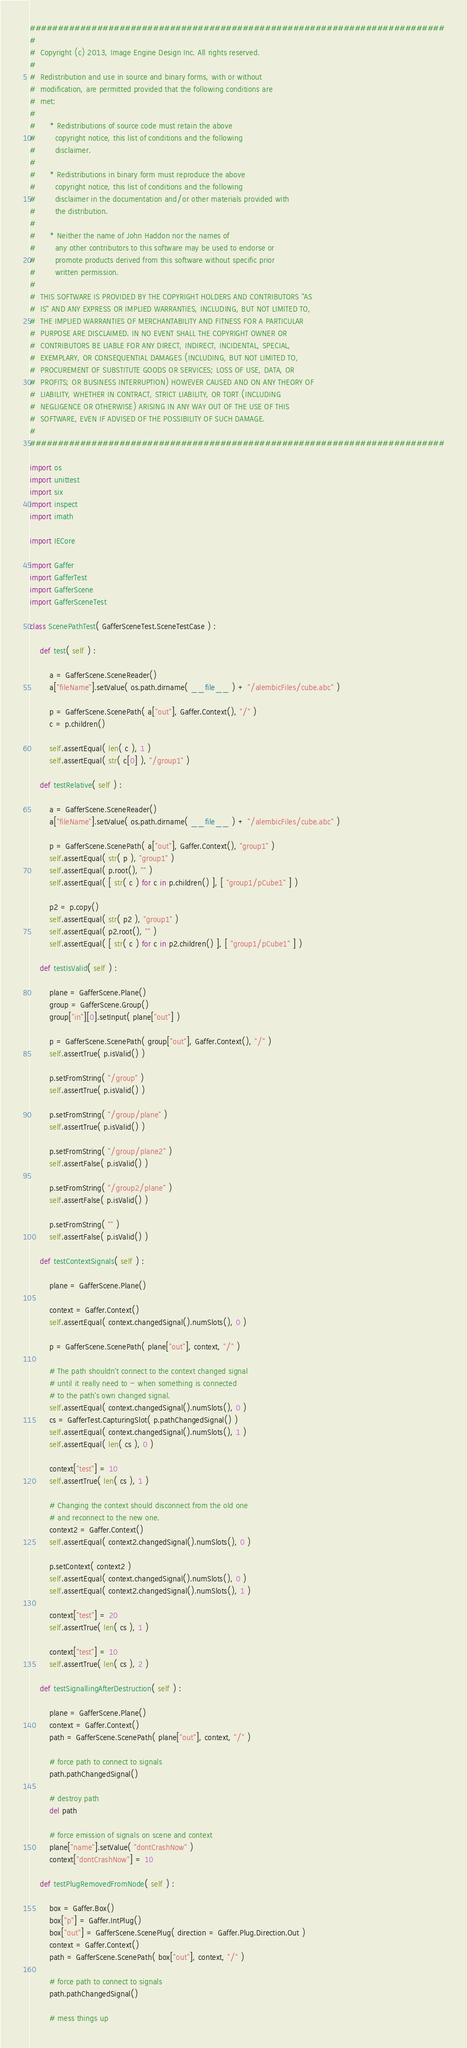Convert code to text. <code><loc_0><loc_0><loc_500><loc_500><_Python_>##########################################################################
#
#  Copyright (c) 2013, Image Engine Design Inc. All rights reserved.
#
#  Redistribution and use in source and binary forms, with or without
#  modification, are permitted provided that the following conditions are
#  met:
#
#      * Redistributions of source code must retain the above
#        copyright notice, this list of conditions and the following
#        disclaimer.
#
#      * Redistributions in binary form must reproduce the above
#        copyright notice, this list of conditions and the following
#        disclaimer in the documentation and/or other materials provided with
#        the distribution.
#
#      * Neither the name of John Haddon nor the names of
#        any other contributors to this software may be used to endorse or
#        promote products derived from this software without specific prior
#        written permission.
#
#  THIS SOFTWARE IS PROVIDED BY THE COPYRIGHT HOLDERS AND CONTRIBUTORS "AS
#  IS" AND ANY EXPRESS OR IMPLIED WARRANTIES, INCLUDING, BUT NOT LIMITED TO,
#  THE IMPLIED WARRANTIES OF MERCHANTABILITY AND FITNESS FOR A PARTICULAR
#  PURPOSE ARE DISCLAIMED. IN NO EVENT SHALL THE COPYRIGHT OWNER OR
#  CONTRIBUTORS BE LIABLE FOR ANY DIRECT, INDIRECT, INCIDENTAL, SPECIAL,
#  EXEMPLARY, OR CONSEQUENTIAL DAMAGES (INCLUDING, BUT NOT LIMITED TO,
#  PROCUREMENT OF SUBSTITUTE GOODS OR SERVICES; LOSS OF USE, DATA, OR
#  PROFITS; OR BUSINESS INTERRUPTION) HOWEVER CAUSED AND ON ANY THEORY OF
#  LIABILITY, WHETHER IN CONTRACT, STRICT LIABILITY, OR TORT (INCLUDING
#  NEGLIGENCE OR OTHERWISE) ARISING IN ANY WAY OUT OF THE USE OF THIS
#  SOFTWARE, EVEN IF ADVISED OF THE POSSIBILITY OF SUCH DAMAGE.
#
##########################################################################

import os
import unittest
import six
import inspect
import imath

import IECore

import Gaffer
import GafferTest
import GafferScene
import GafferSceneTest

class ScenePathTest( GafferSceneTest.SceneTestCase ) :

	def test( self ) :

		a = GafferScene.SceneReader()
		a["fileName"].setValue( os.path.dirname( __file__ ) + "/alembicFiles/cube.abc" )

		p = GafferScene.ScenePath( a["out"], Gaffer.Context(), "/" )
		c = p.children()

		self.assertEqual( len( c ), 1 )
		self.assertEqual( str( c[0] ), "/group1" )

	def testRelative( self ) :

		a = GafferScene.SceneReader()
		a["fileName"].setValue( os.path.dirname( __file__ ) + "/alembicFiles/cube.abc" )

		p = GafferScene.ScenePath( a["out"], Gaffer.Context(), "group1" )
		self.assertEqual( str( p ), "group1" )
		self.assertEqual( p.root(), "" )
		self.assertEqual( [ str( c ) for c in p.children() ], [ "group1/pCube1" ] )

		p2 = p.copy()
		self.assertEqual( str( p2 ), "group1" )
		self.assertEqual( p2.root(), "" )
		self.assertEqual( [ str( c ) for c in p2.children() ], [ "group1/pCube1" ] )

	def testIsValid( self ) :

		plane = GafferScene.Plane()
		group = GafferScene.Group()
		group["in"][0].setInput( plane["out"] )

		p = GafferScene.ScenePath( group["out"], Gaffer.Context(), "/" )
		self.assertTrue( p.isValid() )

		p.setFromString( "/group" )
		self.assertTrue( p.isValid() )

		p.setFromString( "/group/plane" )
		self.assertTrue( p.isValid() )

		p.setFromString( "/group/plane2" )
		self.assertFalse( p.isValid() )

		p.setFromString( "/group2/plane" )
		self.assertFalse( p.isValid() )

		p.setFromString( "" )
		self.assertFalse( p.isValid() )

	def testContextSignals( self ) :

		plane = GafferScene.Plane()

		context = Gaffer.Context()
		self.assertEqual( context.changedSignal().numSlots(), 0 )

		p = GafferScene.ScenePath( plane["out"], context, "/" )

		# The path shouldn't connect to the context changed signal
		# until it really need to - when something is connected
		# to the path's own changed signal.
		self.assertEqual( context.changedSignal().numSlots(), 0 )
		cs = GafferTest.CapturingSlot( p.pathChangedSignal() )
		self.assertEqual( context.changedSignal().numSlots(), 1 )
		self.assertEqual( len( cs ), 0 )

		context["test"] = 10
		self.assertTrue( len( cs ), 1 )

		# Changing the context should disconnect from the old one
		# and reconnect to the new one.
		context2 = Gaffer.Context()
		self.assertEqual( context2.changedSignal().numSlots(), 0 )

		p.setContext( context2 )
		self.assertEqual( context.changedSignal().numSlots(), 0 )
		self.assertEqual( context2.changedSignal().numSlots(), 1 )

		context["test"] = 20
		self.assertTrue( len( cs ), 1 )

		context["test"] = 10
		self.assertTrue( len( cs ), 2 )

	def testSignallingAfterDestruction( self ) :

		plane = GafferScene.Plane()
		context = Gaffer.Context()
		path = GafferScene.ScenePath( plane["out"], context, "/" )

		# force path to connect to signals
		path.pathChangedSignal()

		# destroy path
		del path

		# force emission of signals on scene and context
		plane["name"].setValue( "dontCrashNow" )
		context["dontCrashNow"] = 10

	def testPlugRemovedFromNode( self ) :

		box = Gaffer.Box()
		box["p"] = Gaffer.IntPlug()
		box["out"] = GafferScene.ScenePlug( direction = Gaffer.Plug.Direction.Out )
		context = Gaffer.Context()
		path = GafferScene.ScenePath( box["out"], context, "/" )

		# force path to connect to signals
		path.pathChangedSignal()

		# mess things up</code> 